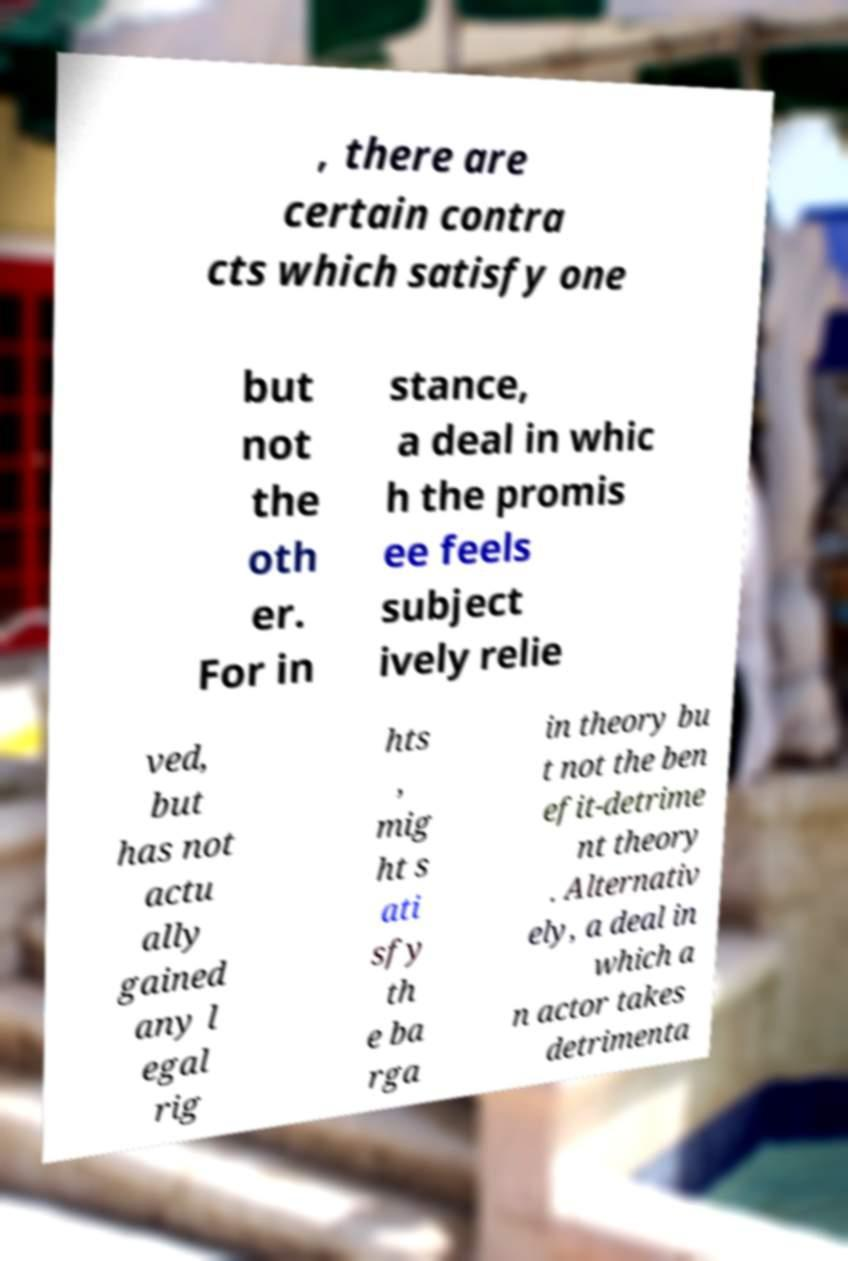There's text embedded in this image that I need extracted. Can you transcribe it verbatim? , there are certain contra cts which satisfy one but not the oth er. For in stance, a deal in whic h the promis ee feels subject ively relie ved, but has not actu ally gained any l egal rig hts , mig ht s ati sfy th e ba rga in theory bu t not the ben efit-detrime nt theory . Alternativ ely, a deal in which a n actor takes detrimenta 